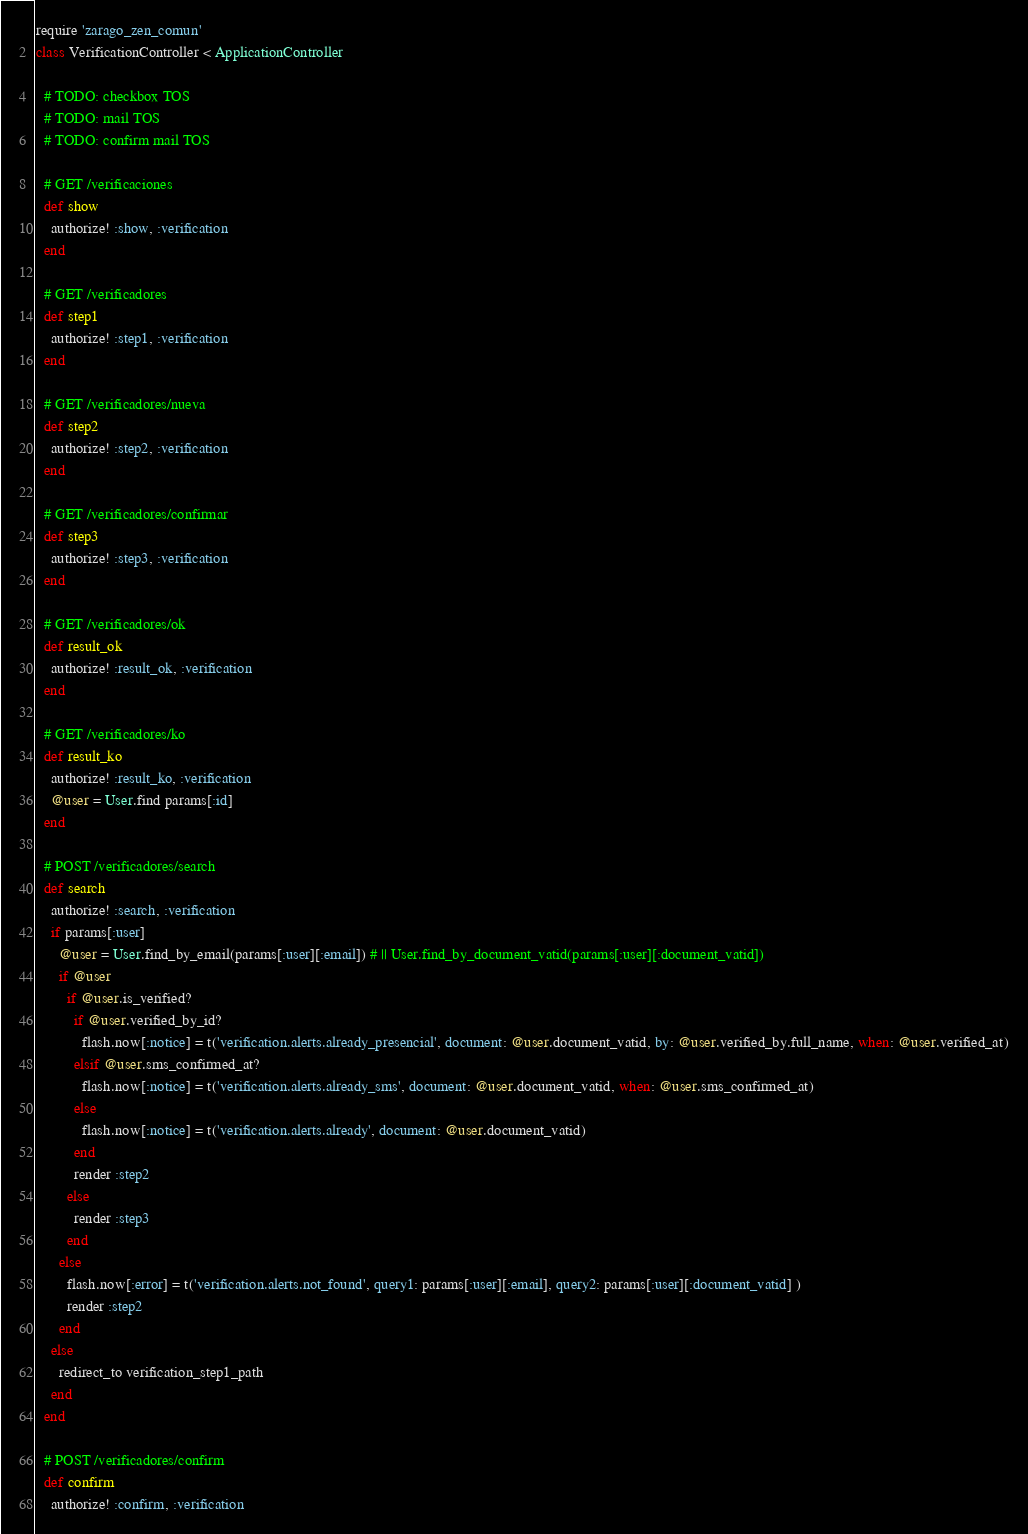<code> <loc_0><loc_0><loc_500><loc_500><_Ruby_>require 'zarago_zen_comun'
class VerificationController < ApplicationController

  # TODO: checkbox TOS
  # TODO: mail TOS
  # TODO: confirm mail TOS
 
  # GET /verificaciones
  def show
    authorize! :show, :verification
  end

  # GET /verificadores
  def step1
    authorize! :step1, :verification
  end

  # GET /verificadores/nueva
  def step2
    authorize! :step2, :verification
  end

  # GET /verificadores/confirmar
  def step3
    authorize! :step3, :verification
  end

  # GET /verificadores/ok
  def result_ok
    authorize! :result_ok, :verification
  end

  # GET /verificadores/ko
  def result_ko
    authorize! :result_ko, :verification
    @user = User.find params[:id]
  end

  # POST /verificadores/search
  def search
    authorize! :search, :verification
    if params[:user]
      @user = User.find_by_email(params[:user][:email]) # || User.find_by_document_vatid(params[:user][:document_vatid])
      if @user
        if @user.is_verified? 
          if @user.verified_by_id?
            flash.now[:notice] = t('verification.alerts.already_presencial', document: @user.document_vatid, by: @user.verified_by.full_name, when: @user.verified_at)
          elsif @user.sms_confirmed_at? 
            flash.now[:notice] = t('verification.alerts.already_sms', document: @user.document_vatid, when: @user.sms_confirmed_at)
          else 
            flash.now[:notice] = t('verification.alerts.already', document: @user.document_vatid)
          end
          render :step2
        else
          render :step3
        end
      else 
        flash.now[:error] = t('verification.alerts.not_found', query1: params[:user][:email], query2: params[:user][:document_vatid] )
        render :step2
      end
    else
      redirect_to verification_step1_path
    end
  end
  
  # POST /verificadores/confirm
  def confirm
    authorize! :confirm, :verification</code> 